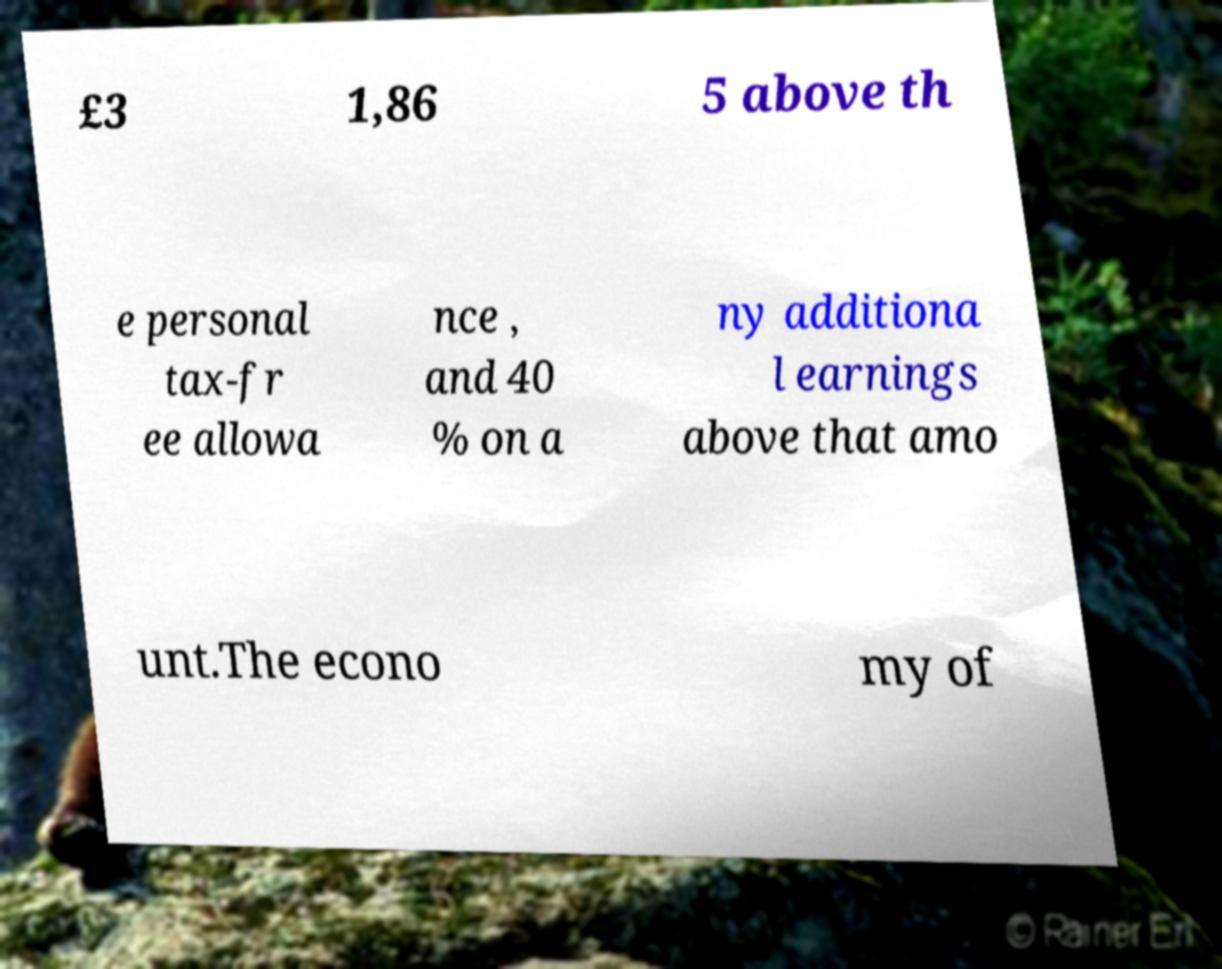Can you accurately transcribe the text from the provided image for me? £3 1,86 5 above th e personal tax-fr ee allowa nce , and 40 % on a ny additiona l earnings above that amo unt.The econo my of 